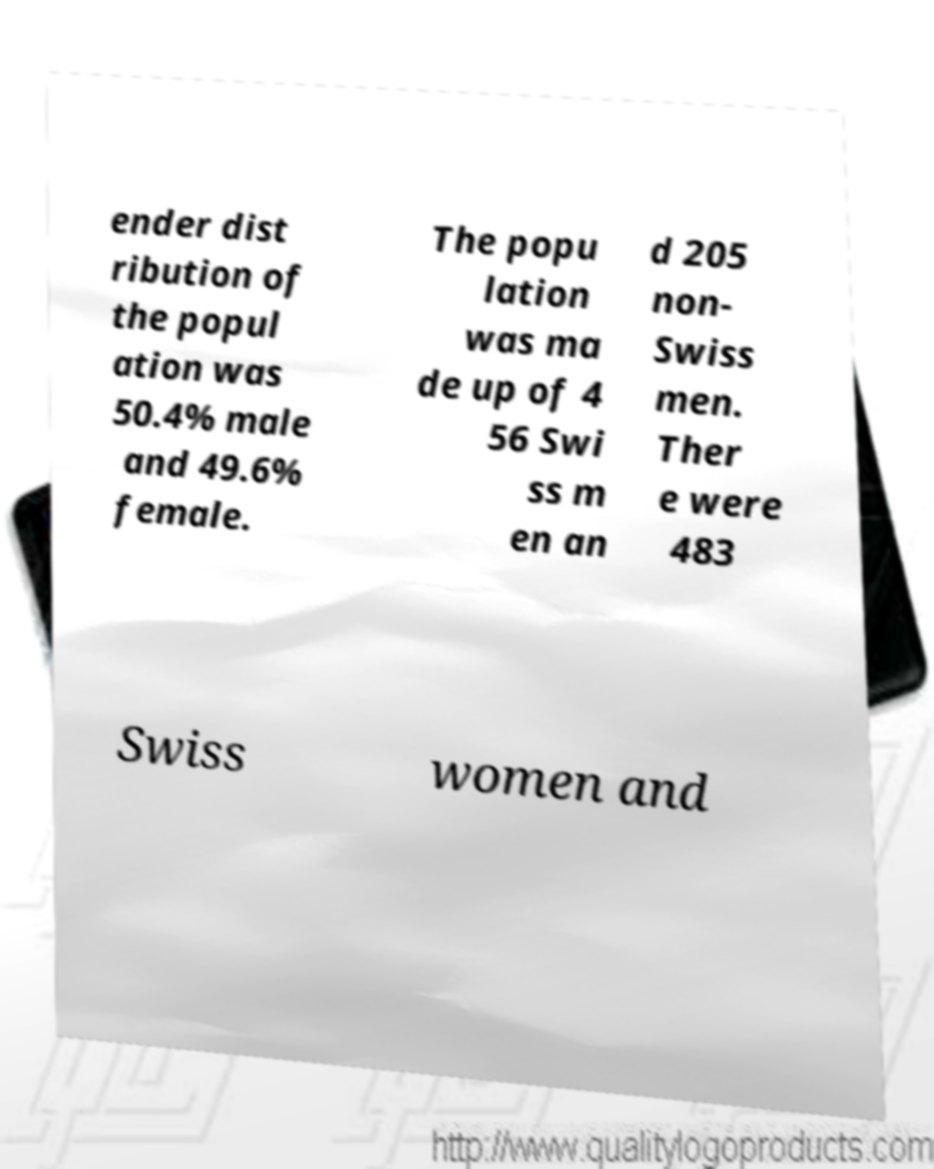Could you assist in decoding the text presented in this image and type it out clearly? ender dist ribution of the popul ation was 50.4% male and 49.6% female. The popu lation was ma de up of 4 56 Swi ss m en an d 205 non- Swiss men. Ther e were 483 Swiss women and 